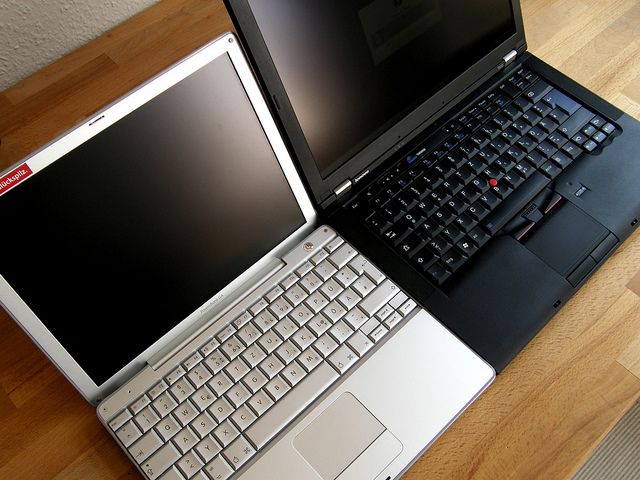Read all the text in this image. U R M N B L K H P O Y V D O 0 J O I 0 9 8 M N B V C K J H G I U Y 7 6 5 T 4 Z F D R E W 4 3 2 1 